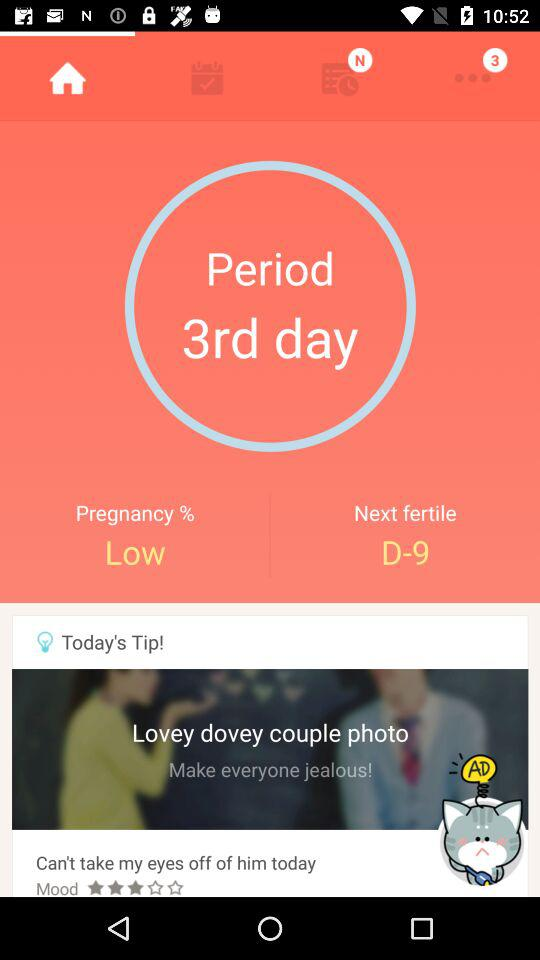What is the next fertile? The next fertile is D-9. 